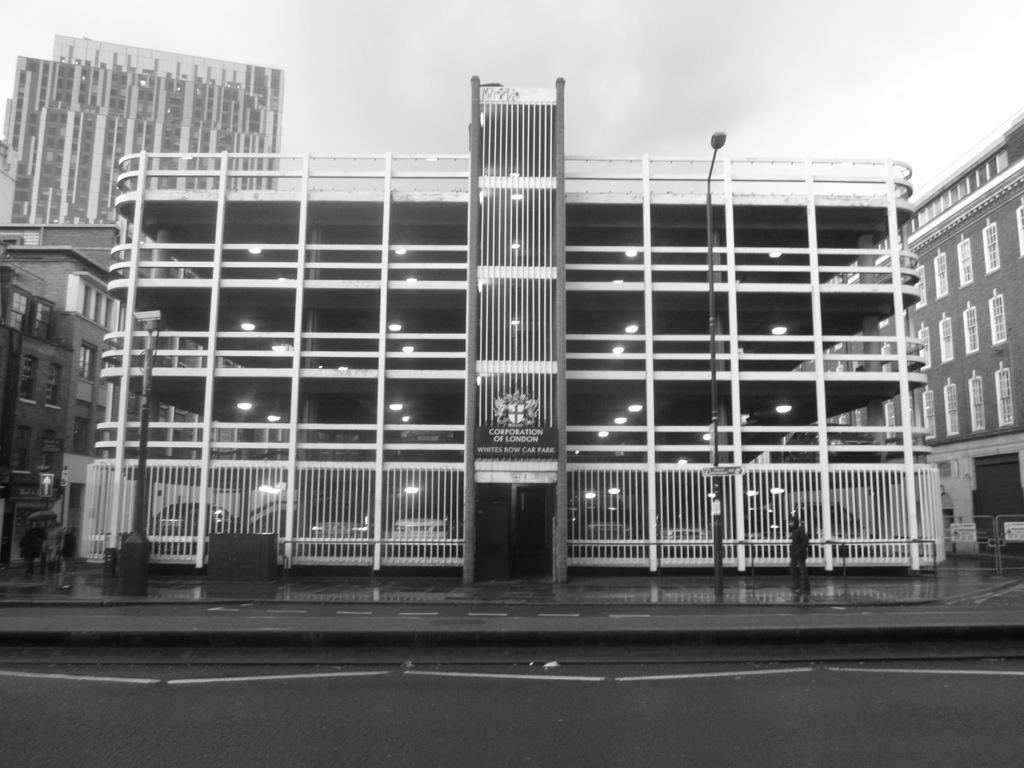Can you describe this image briefly? In the image we can see there are buildings and a person is standing on the footpath. There is a street light pole on the footpath and the image is in black and white colour. 